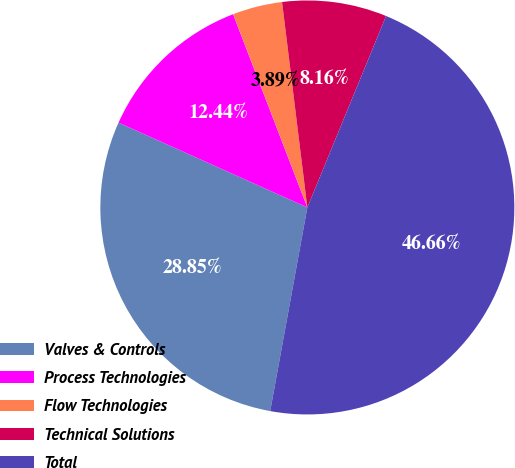<chart> <loc_0><loc_0><loc_500><loc_500><pie_chart><fcel>Valves & Controls<fcel>Process Technologies<fcel>Flow Technologies<fcel>Technical Solutions<fcel>Total<nl><fcel>28.85%<fcel>12.44%<fcel>3.89%<fcel>8.16%<fcel>46.66%<nl></chart> 